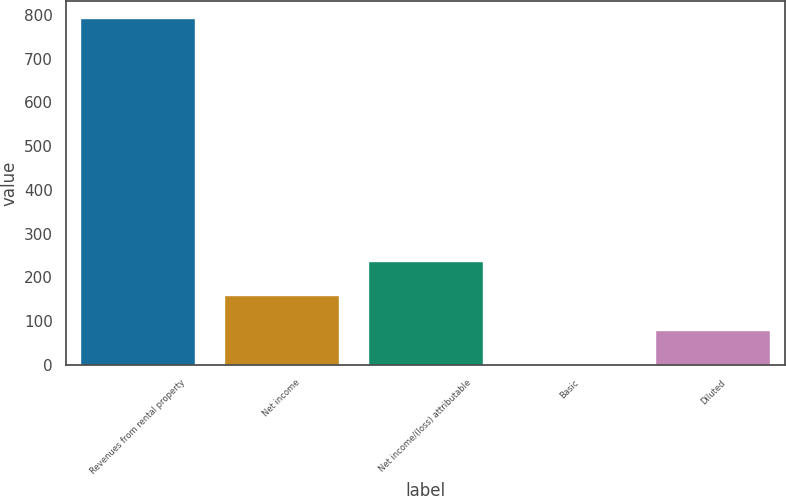<chart> <loc_0><loc_0><loc_500><loc_500><bar_chart><fcel>Revenues from rental property<fcel>Net income<fcel>Net income/(loss) attributable<fcel>Basic<fcel>Diluted<nl><fcel>792.7<fcel>158.62<fcel>237.88<fcel>0.1<fcel>79.36<nl></chart> 